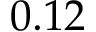Convert formula to latex. <formula><loc_0><loc_0><loc_500><loc_500>0 . 1 2</formula> 